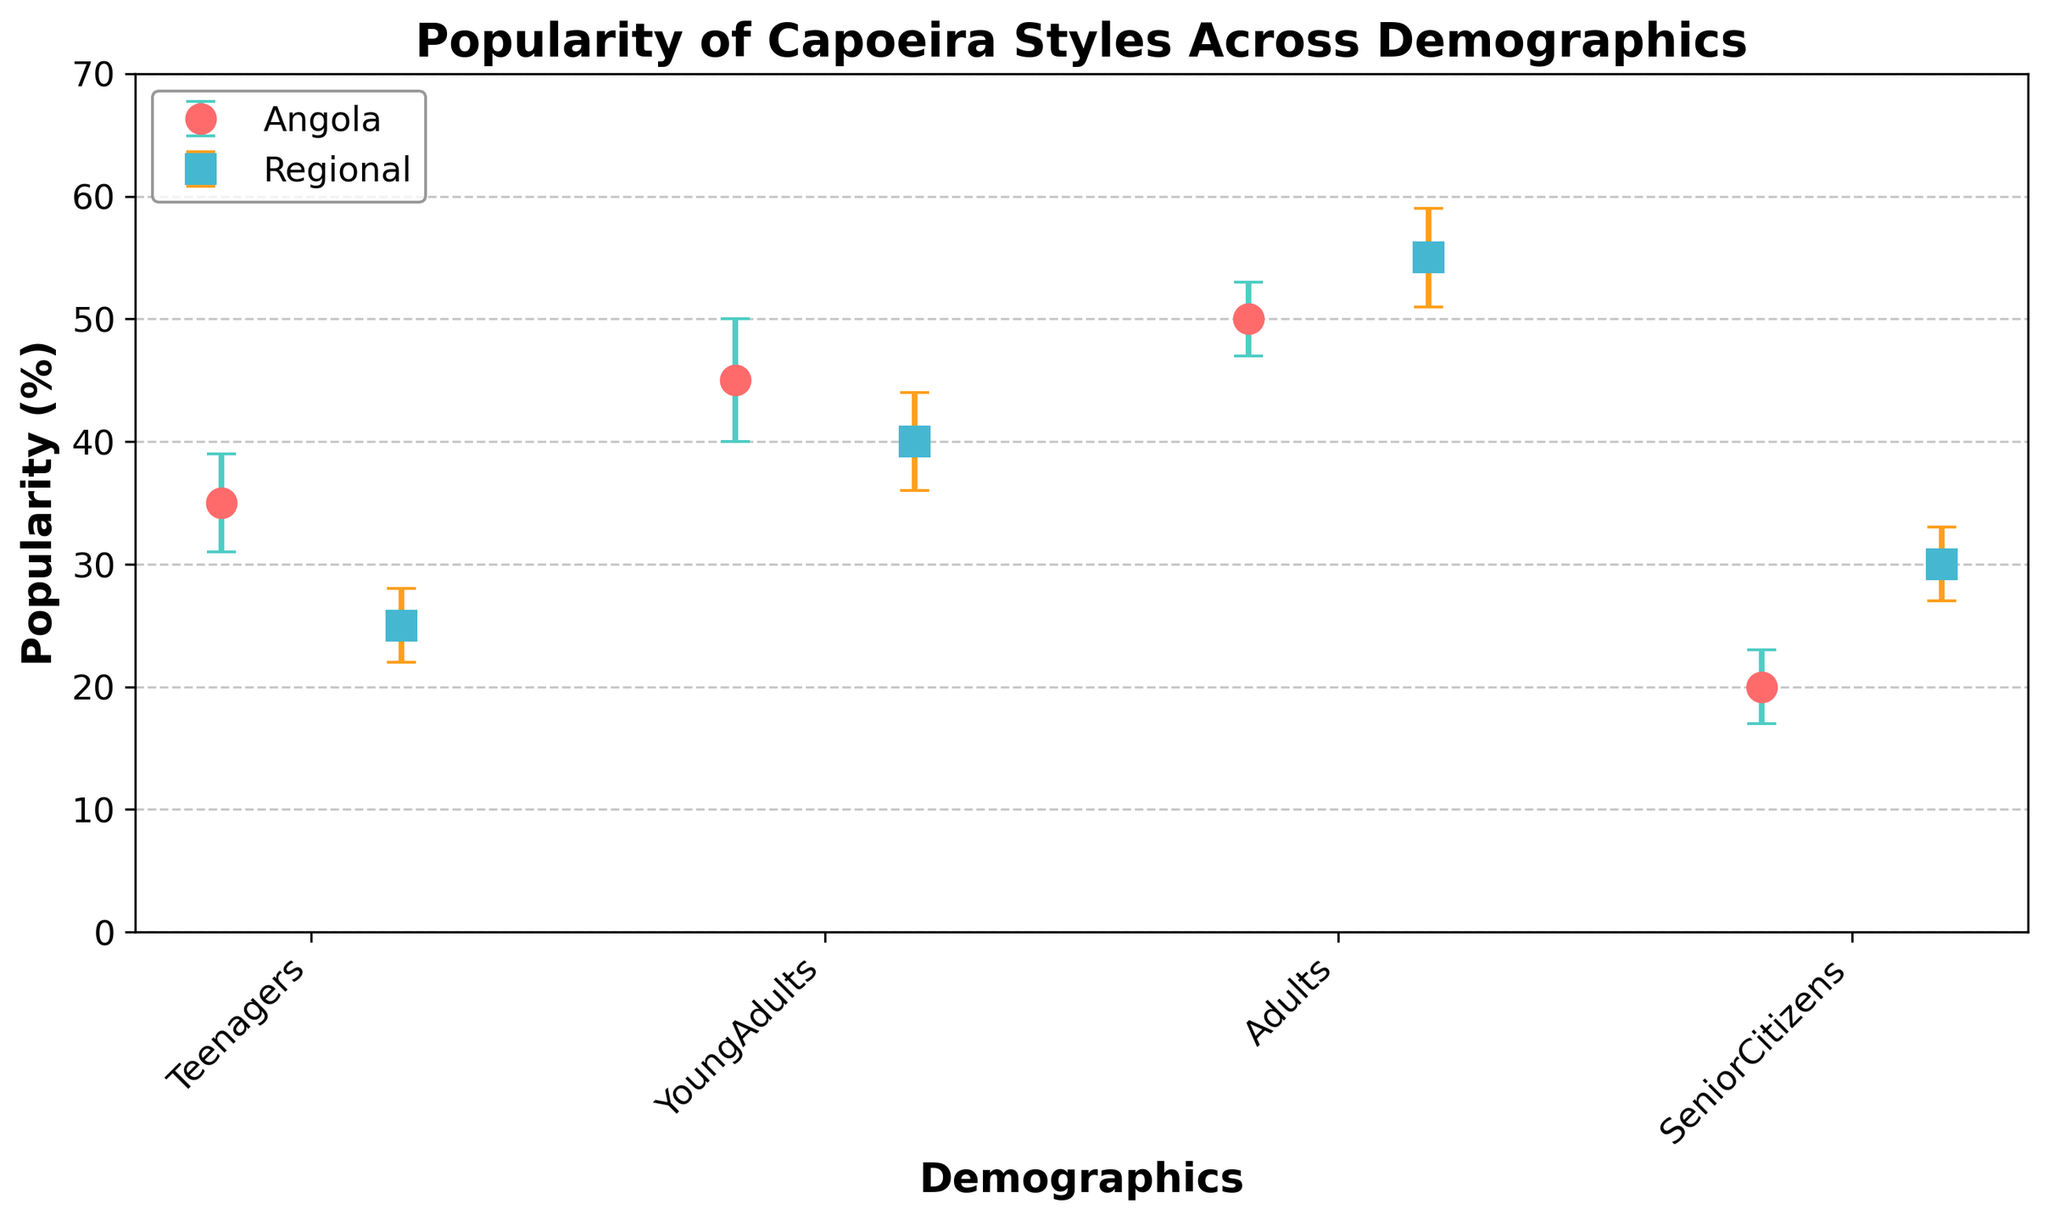Which demographic shows the highest popularity for Capoeira Angola? The popularity percentages for Capoeira Angola are as follows: Teenagers (35%), YoungAdults (45%), Adults (50%), and SeniorCitizens (20%). Among these groups, Adults have the highest popularity at 50%.
Answer: Adults What is the total popularity of Capoeira Regional among Young Adults and Adults combined? The popularity of Capoeira Regional in Young Adults is 40%, and in Adults, it is 55%. Adding these two percentages: 40% + 55% = 95%.
Answer: 95% Which style of Capoeira has a higher popularity among teenagers, Angola or Regional? According to the figure, the popularity of Capoeira Angola among teenagers is 35%, whereas for Capoeira Regional, it is 25%. Since 35% is greater than 25%, Capoeira Angola is more popular among teenagers.
Answer: Angola What is the difference in popularity between Capoeira Angola and Capoeira Regional among Senior Citizens? The popularity of Capoeira Angola among Senior Citizens is 20%, while for Capoeira Regional it is 30%. The difference in popularity is 30% - 20% = 10%.
Answer: 10% Which demographic group has the smallest margin of error for Capoeira Angola? The margins of error for Capoeira Angola across different demographics are Teenagers (4%), YoungAdults (5%), Adults (3%), and SeniorCitizens (3%). Adults and SeniorCitizens both have the smallest margin of error at 3%.
Answer: Adults and SeniorCitizens Between which two demographic groups does Capoeira Angola show a larger popularity margin in terms of error for Young Adults compared to Capoeira Regional? For Capoeira Angola among Young Adults, the margin of error is 5%, while for Capoeira Regional among Young Adults, it is 4%. The margin of error for Capoeira Angola is larger by 1%.
Answer: Young Adults What is the combined margin of error for Capoeira Regional for Teenagers and Senior Citizens? The margin of error for Capoeira Regional is 3% for both Teenagers and Senior Citizens. Adding these two errors: 3% + 3% = 6%.
Answer: 6% How does the popularity of Capoeira Angola among Adults compare to Capoeira Regional among Adults? The popularity percentage for Capoeira Angola among Adults is 50%, whereas for Capoeira Regional among Adults, it is 55%. Therefore, Capoeira Regional is more popular among Adults by 5%.
Answer: Capoeira Regional by 5% 